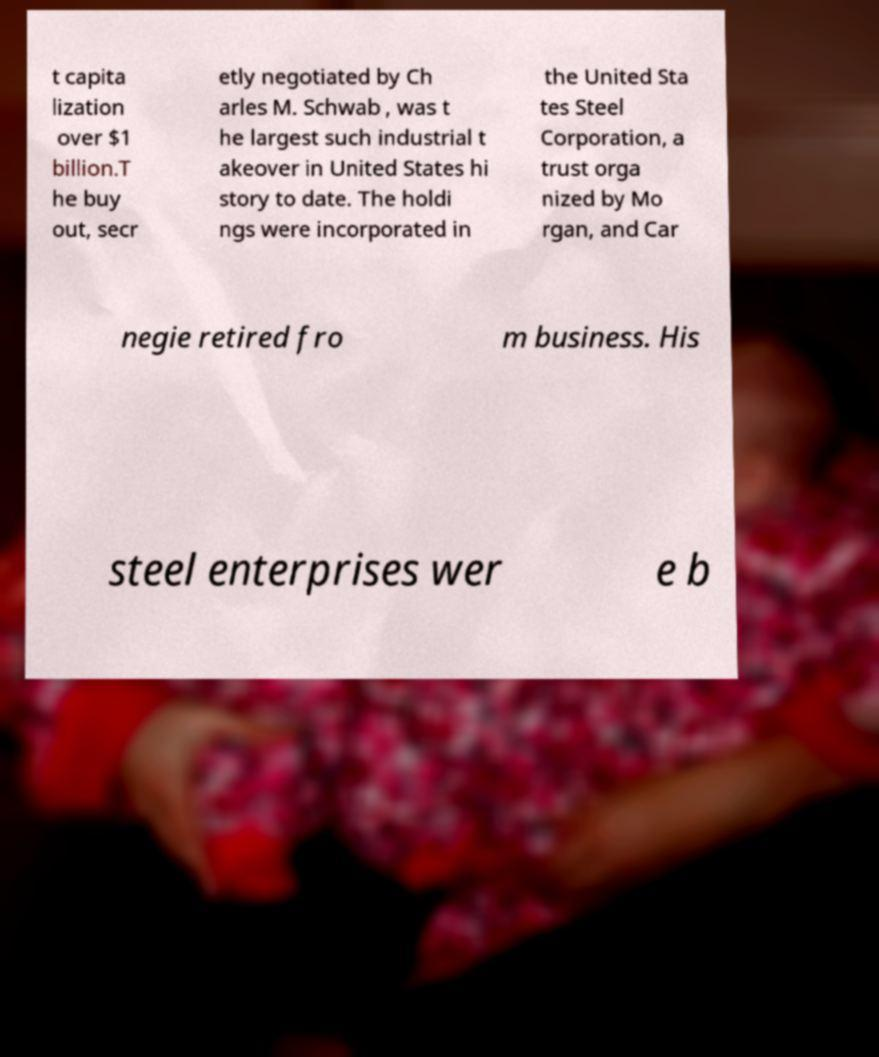Could you assist in decoding the text presented in this image and type it out clearly? t capita lization over $1 billion.T he buy out, secr etly negotiated by Ch arles M. Schwab , was t he largest such industrial t akeover in United States hi story to date. The holdi ngs were incorporated in the United Sta tes Steel Corporation, a trust orga nized by Mo rgan, and Car negie retired fro m business. His steel enterprises wer e b 